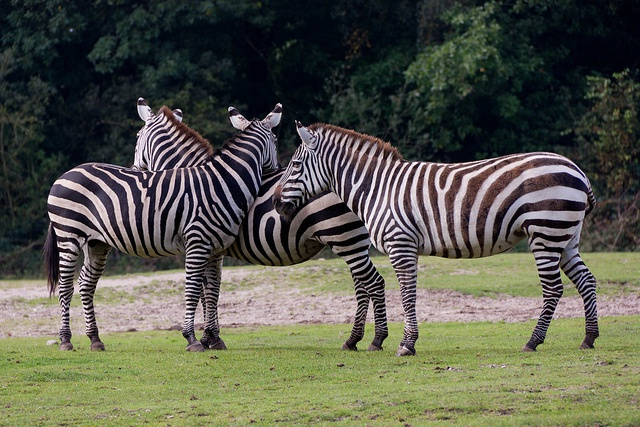Describe the objects in this image and their specific colors. I can see zebra in black, darkgray, gray, and lightgray tones, zebra in black, darkgray, gray, and lightgray tones, and zebra in black, gray, darkgray, and lightgray tones in this image. 